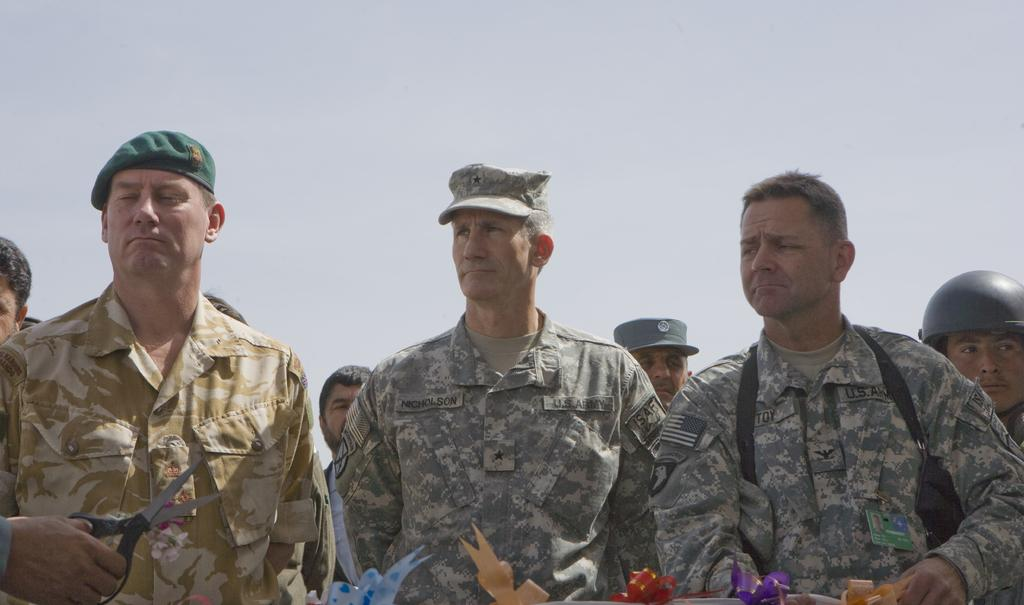What is happening in the foreground of the image? There are people standing in the foreground of the image. What is the person at the bottom side of the image holding? The person is holding scissors and ribbons. What color is the background of the image? The background of the image is white. What type of bat is flying in the image? There is no bat present in the image. What flavor of juice is being served in the image? There is no juice present in the image. 